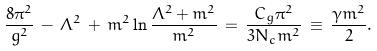<formula> <loc_0><loc_0><loc_500><loc_500>\frac { 8 \pi ^ { 2 } } { g ^ { 2 } } \, - \, \Lambda ^ { 2 } \, + \, m ^ { 2 } \ln \frac { \Lambda ^ { 2 } + m ^ { 2 } } { m ^ { 2 } } \, = \, \frac { C _ { g } \pi ^ { 2 } } { 3 N _ { c } m ^ { 2 } } \, \equiv \, \frac { \gamma m ^ { 2 } } { 2 } .</formula> 